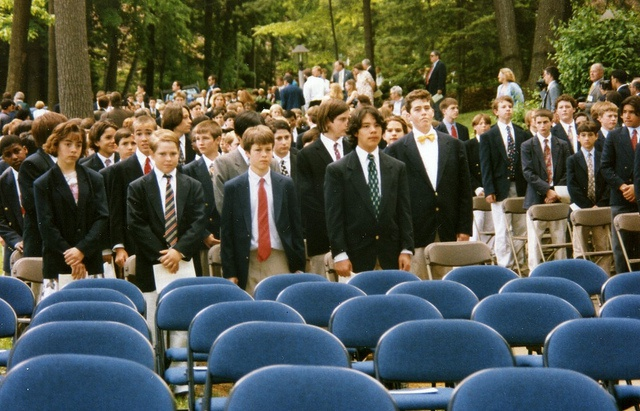Describe the objects in this image and their specific colors. I can see people in khaki, black, olive, tan, and lightgray tones, chair in khaki, blue, black, gray, and darkblue tones, people in khaki, black, lightgray, gray, and brown tones, people in khaki, black, lightgray, and gray tones, and people in khaki, black, brown, lightgray, and maroon tones in this image. 